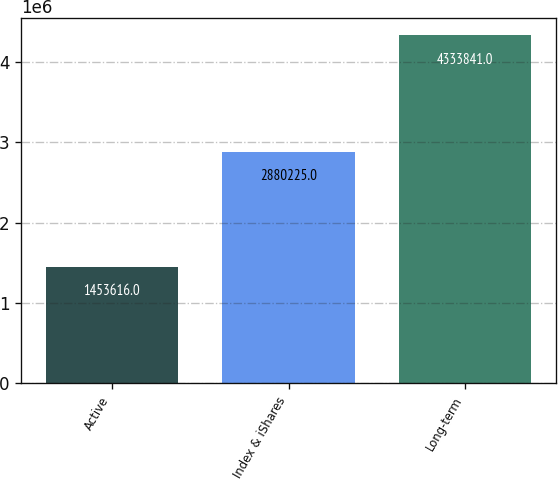<chart> <loc_0><loc_0><loc_500><loc_500><bar_chart><fcel>Active<fcel>Index & iShares<fcel>Long-term<nl><fcel>1.45362e+06<fcel>2.88022e+06<fcel>4.33384e+06<nl></chart> 